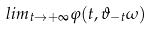<formula> <loc_0><loc_0><loc_500><loc_500>l i m _ { t \rightarrow + \infty } \varphi ( t , \vartheta _ { - t } \omega )</formula> 